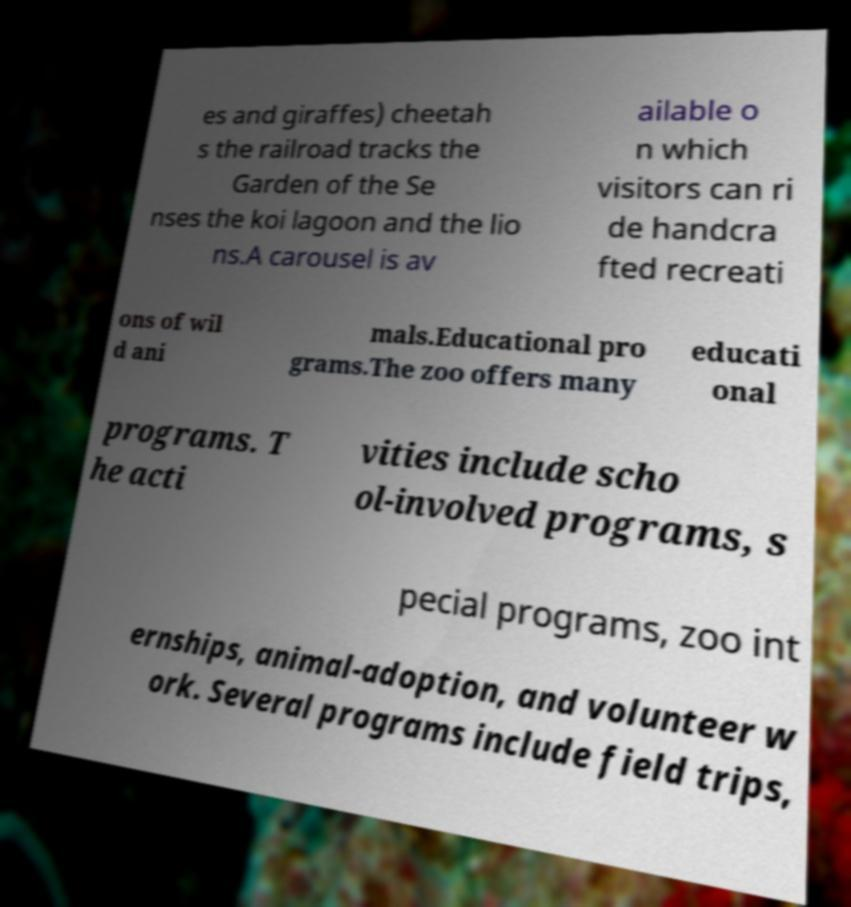Could you assist in decoding the text presented in this image and type it out clearly? es and giraffes) cheetah s the railroad tracks the Garden of the Se nses the koi lagoon and the lio ns.A carousel is av ailable o n which visitors can ri de handcra fted recreati ons of wil d ani mals.Educational pro grams.The zoo offers many educati onal programs. T he acti vities include scho ol-involved programs, s pecial programs, zoo int ernships, animal-adoption, and volunteer w ork. Several programs include field trips, 